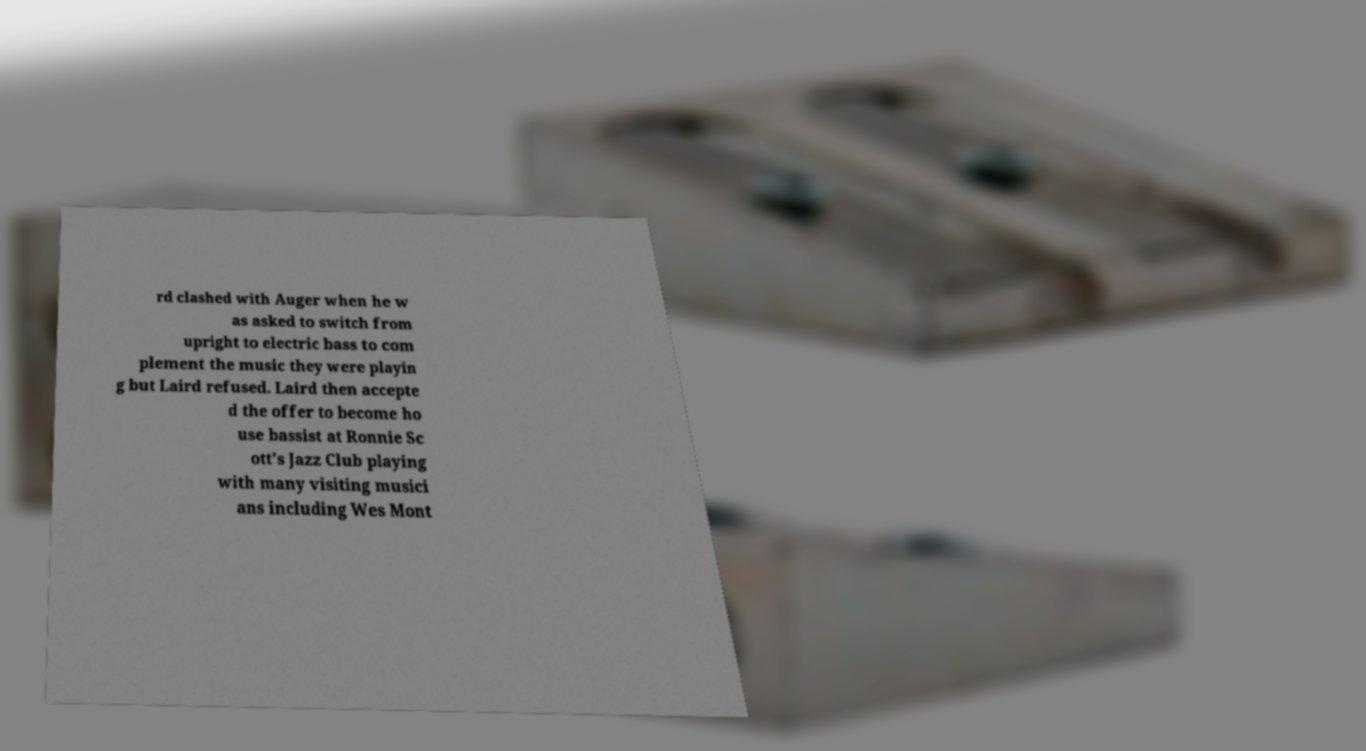Could you assist in decoding the text presented in this image and type it out clearly? rd clashed with Auger when he w as asked to switch from upright to electric bass to com plement the music they were playin g but Laird refused. Laird then accepte d the offer to become ho use bassist at Ronnie Sc ott's Jazz Club playing with many visiting musici ans including Wes Mont 